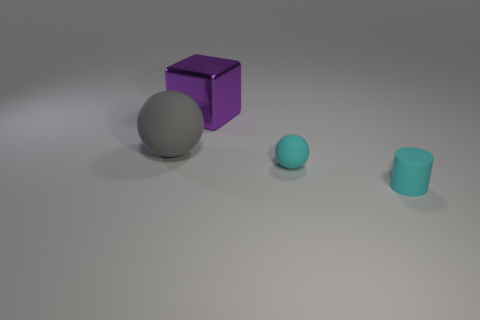Add 3 large green cylinders. How many objects exist? 7 Subtract all cylinders. How many objects are left? 3 Subtract 1 purple blocks. How many objects are left? 3 Subtract all small spheres. Subtract all spheres. How many objects are left? 1 Add 4 cyan objects. How many cyan objects are left? 6 Add 4 metallic cubes. How many metallic cubes exist? 5 